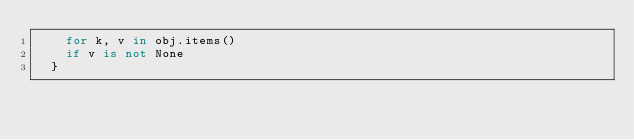Convert code to text. <code><loc_0><loc_0><loc_500><loc_500><_Python_>    for k, v in obj.items()
    if v is not None
  }
</code> 